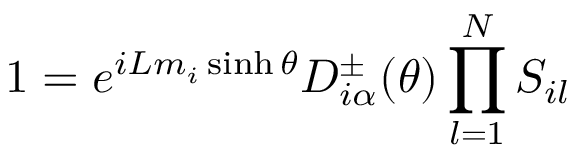<formula> <loc_0><loc_0><loc_500><loc_500>1 = e ^ { i L m _ { i } \sinh \theta } D _ { i \alpha } ^ { \pm } ( \theta ) \prod _ { l = 1 } ^ { N } S _ { i l }</formula> 